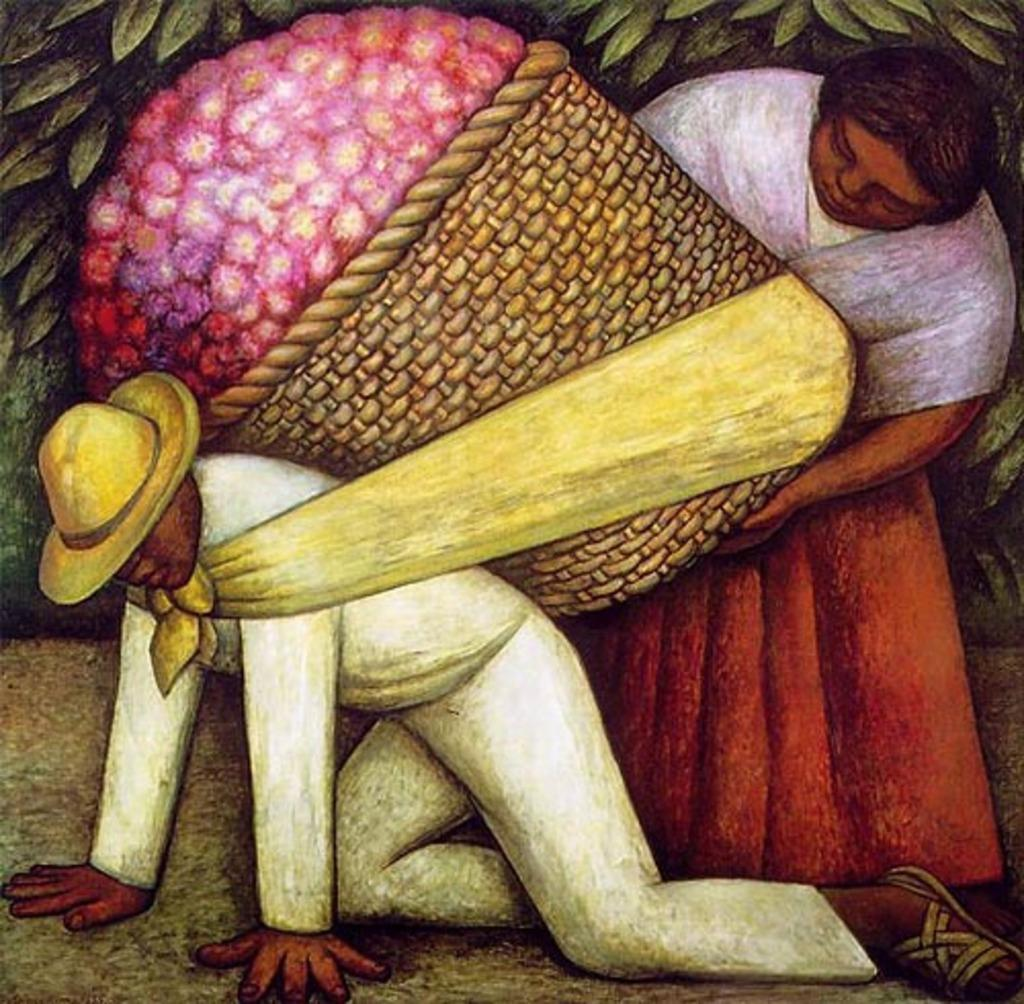What is the main subject of the image? There is a painting in the image. What is depicted in the painting? The painting depicts two persons. What are the two persons doing in the painting? One person is carrying a bag, and the other person is holding the bag. What can be seen in the background of the painting? There are leaves visible in the background of the painting. What type of health request can be seen in the image? There is no health request present in the image; it features a painting of two persons with a bag. 